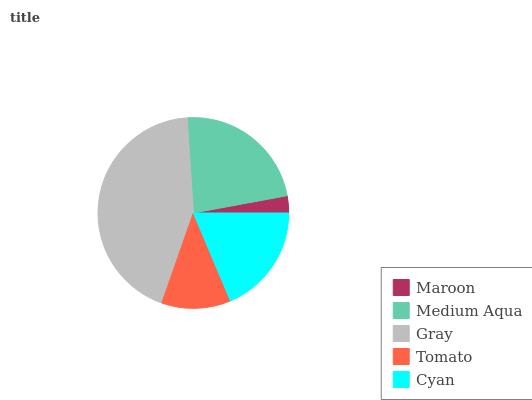Is Maroon the minimum?
Answer yes or no. Yes. Is Gray the maximum?
Answer yes or no. Yes. Is Medium Aqua the minimum?
Answer yes or no. No. Is Medium Aqua the maximum?
Answer yes or no. No. Is Medium Aqua greater than Maroon?
Answer yes or no. Yes. Is Maroon less than Medium Aqua?
Answer yes or no. Yes. Is Maroon greater than Medium Aqua?
Answer yes or no. No. Is Medium Aqua less than Maroon?
Answer yes or no. No. Is Cyan the high median?
Answer yes or no. Yes. Is Cyan the low median?
Answer yes or no. Yes. Is Maroon the high median?
Answer yes or no. No. Is Gray the low median?
Answer yes or no. No. 